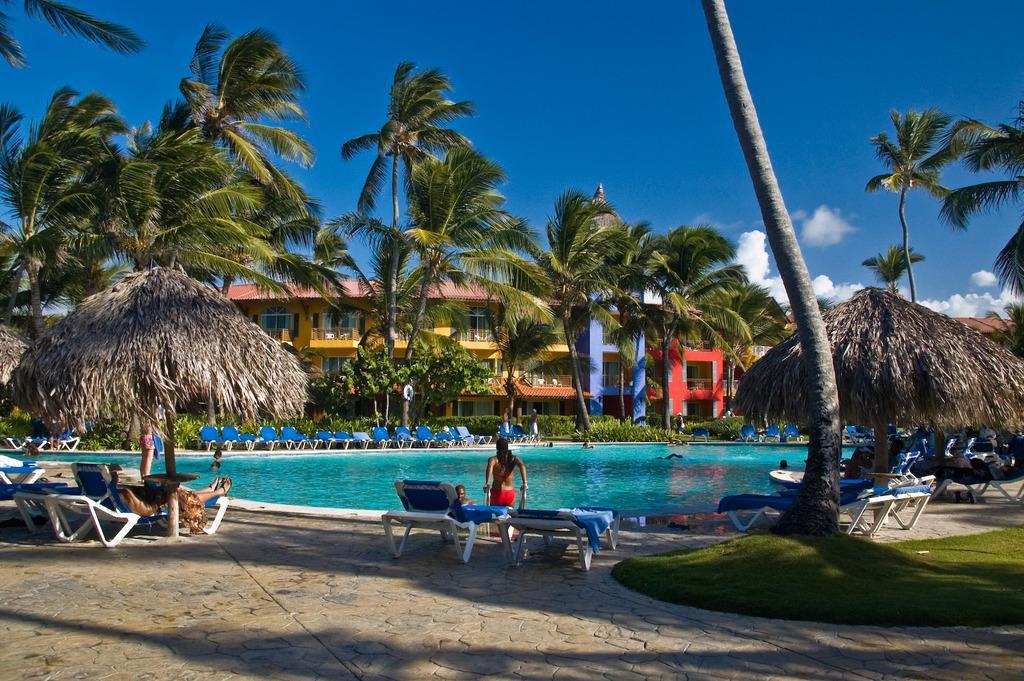Could you give a brief overview of what you see in this image? In this picture we can see chairs, people on the ground, here we can see water, boat, trees, grass and in the background we can see buildings, sky with clouds. 